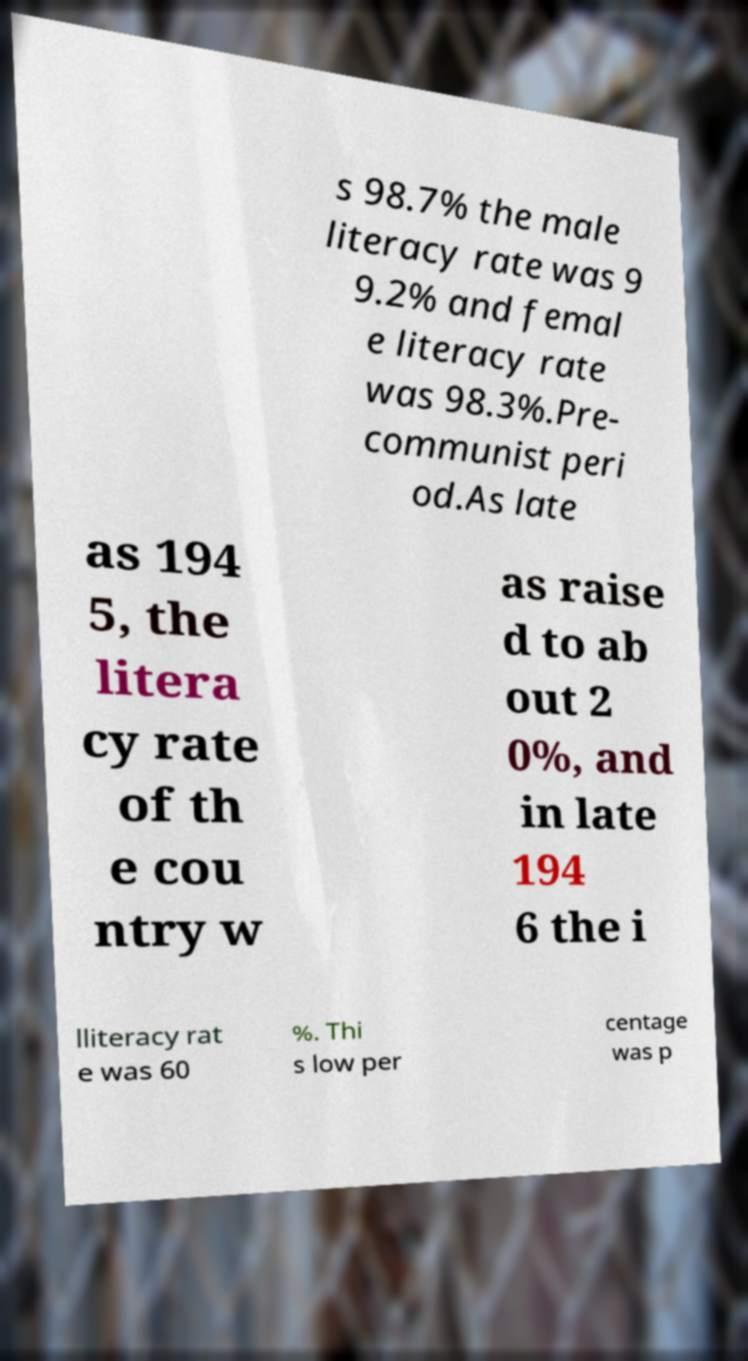I need the written content from this picture converted into text. Can you do that? s 98.7% the male literacy rate was 9 9.2% and femal e literacy rate was 98.3%.Pre- communist peri od.As late as 194 5, the litera cy rate of th e cou ntry w as raise d to ab out 2 0%, and in late 194 6 the i lliteracy rat e was 60 %. Thi s low per centage was p 